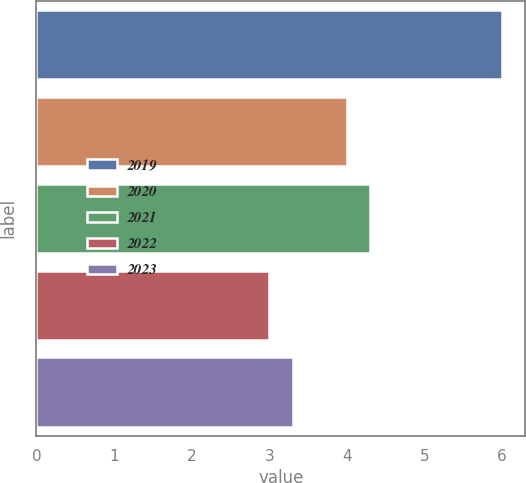Convert chart to OTSL. <chart><loc_0><loc_0><loc_500><loc_500><bar_chart><fcel>2019<fcel>2020<fcel>2021<fcel>2022<fcel>2023<nl><fcel>6<fcel>4<fcel>4.3<fcel>3<fcel>3.3<nl></chart> 